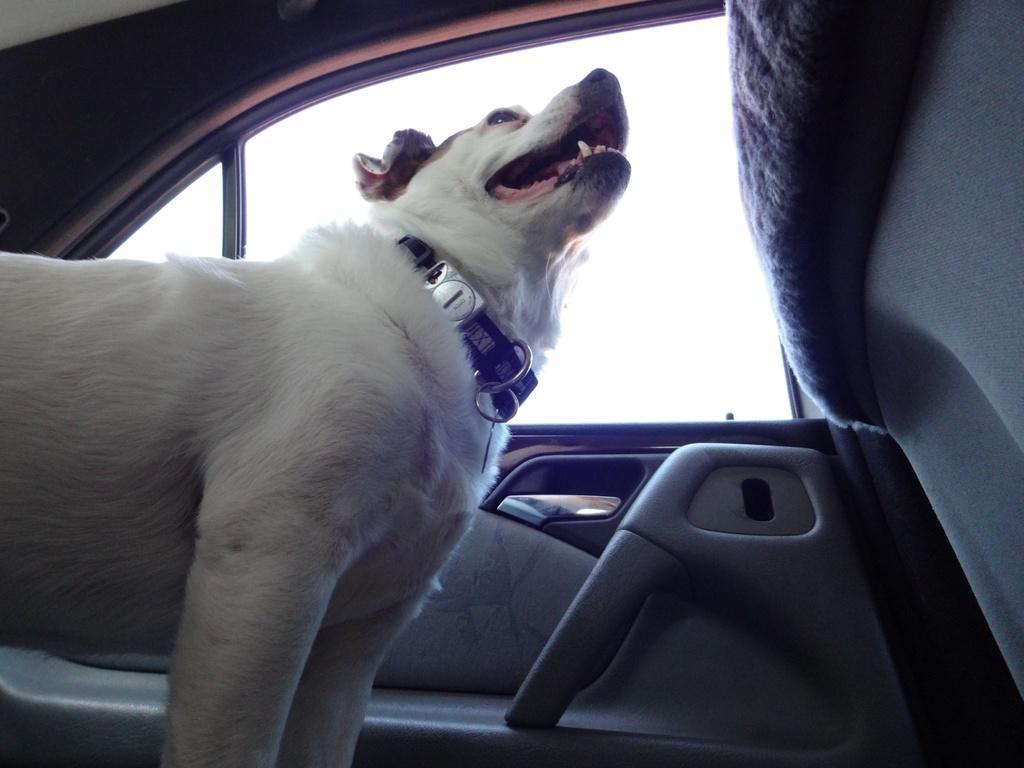Can you describe this image briefly? In this image we can see a dog in the car, and here is the window. 